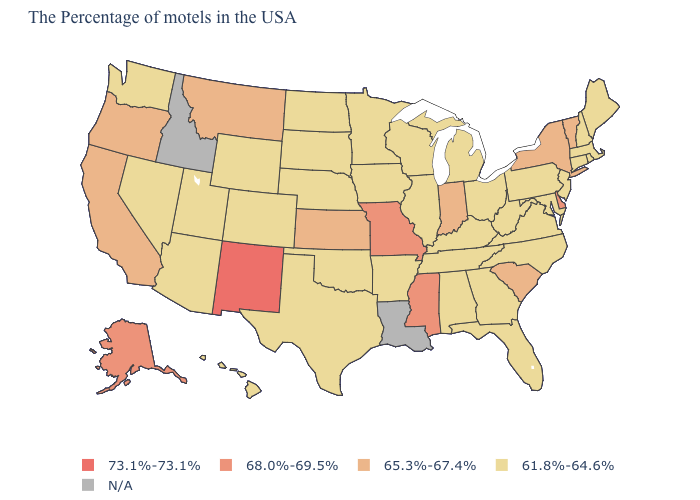What is the value of Mississippi?
Keep it brief. 68.0%-69.5%. What is the value of West Virginia?
Give a very brief answer. 61.8%-64.6%. What is the highest value in the USA?
Quick response, please. 73.1%-73.1%. Does New Jersey have the lowest value in the USA?
Quick response, please. Yes. Does the map have missing data?
Answer briefly. Yes. What is the value of Maine?
Keep it brief. 61.8%-64.6%. Name the states that have a value in the range N/A?
Concise answer only. Louisiana, Idaho. Name the states that have a value in the range N/A?
Keep it brief. Louisiana, Idaho. Name the states that have a value in the range 73.1%-73.1%?
Keep it brief. New Mexico. Name the states that have a value in the range 68.0%-69.5%?
Give a very brief answer. Delaware, Mississippi, Missouri, Alaska. Which states have the highest value in the USA?
Give a very brief answer. New Mexico. Name the states that have a value in the range 73.1%-73.1%?
Short answer required. New Mexico. Name the states that have a value in the range 65.3%-67.4%?
Answer briefly. Vermont, New York, South Carolina, Indiana, Kansas, Montana, California, Oregon. 